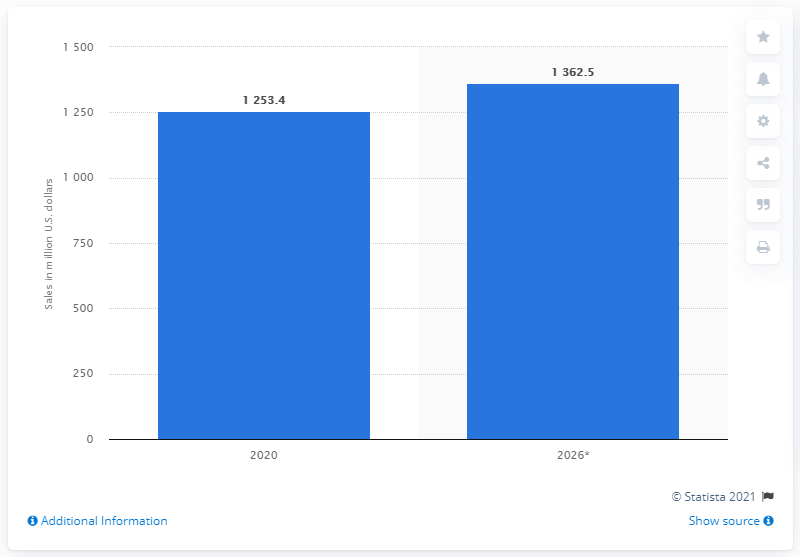Highlight a few significant elements in this photo. The global binoculars market is estimated to be in the year 2020. In the United States in 2020, consumer spending on binoculars was 1253.4 million dollars. 